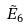Convert formula to latex. <formula><loc_0><loc_0><loc_500><loc_500>\tilde { E } _ { 6 }</formula> 